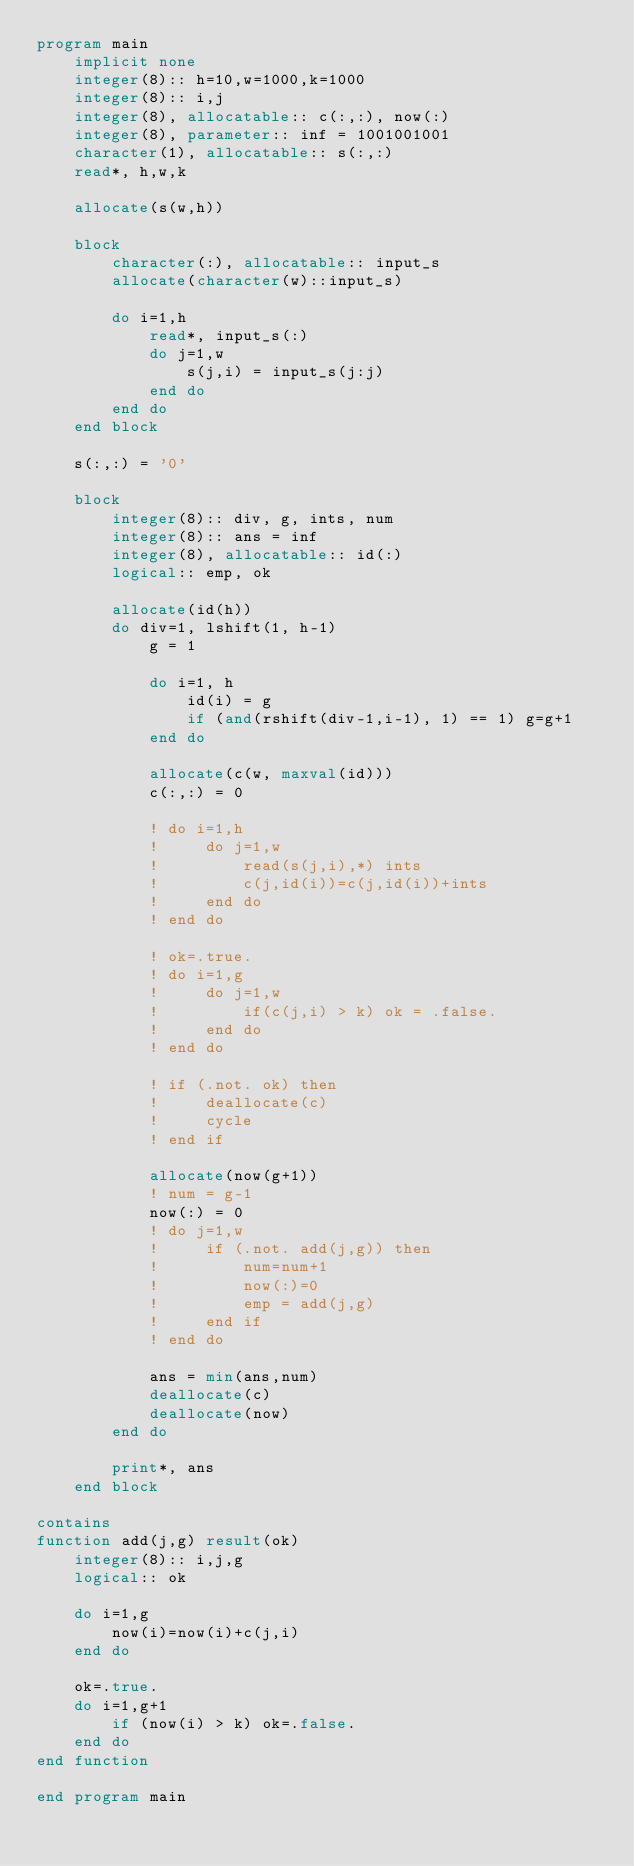Convert code to text. <code><loc_0><loc_0><loc_500><loc_500><_FORTRAN_>program main
    implicit none
    integer(8):: h=10,w=1000,k=1000
    integer(8):: i,j
    integer(8), allocatable:: c(:,:), now(:)
    integer(8), parameter:: inf = 1001001001
    character(1), allocatable:: s(:,:)
    read*, h,w,k
 
    allocate(s(w,h))

    block
        character(:), allocatable:: input_s
        allocate(character(w)::input_s)

        do i=1,h
            read*, input_s(:)
            do j=1,w
                s(j,i) = input_s(j:j)
            end do
        end do
    end block

    s(:,:) = '0'

    block
        integer(8):: div, g, ints, num
        integer(8):: ans = inf
        integer(8), allocatable:: id(:)
        logical:: emp, ok

        allocate(id(h))
        do div=1, lshift(1, h-1)
            g = 1

            do i=1, h
                id(i) = g
                if (and(rshift(div-1,i-1), 1) == 1) g=g+1
            end do

            allocate(c(w, maxval(id)))
            c(:,:) = 0

            ! do i=1,h
            !     do j=1,w
            !         read(s(j,i),*) ints
            !         c(j,id(i))=c(j,id(i))+ints
            !     end do 
            ! end do

            ! ok=.true.
            ! do i=1,g
            !     do j=1,w
            !         if(c(j,i) > k) ok = .false.
            !     end do
            ! end do

            ! if (.not. ok) then
            !     deallocate(c)
            !     cycle
            ! end if

            allocate(now(g+1))
            ! num = g-1
            now(:) = 0
            ! do j=1,w
            !     if (.not. add(j,g)) then
            !         num=num+1
            !         now(:)=0
            !         emp = add(j,g)
            !     end if
            ! end do 

            ans = min(ans,num)
            deallocate(c)
            deallocate(now)
        end do

        print*, ans
    end block

contains
function add(j,g) result(ok)
    integer(8):: i,j,g
    logical:: ok

    do i=1,g
        now(i)=now(i)+c(j,i)
    end do

    ok=.true.
    do i=1,g+1
        if (now(i) > k) ok=.false.
    end do
end function

end program main</code> 